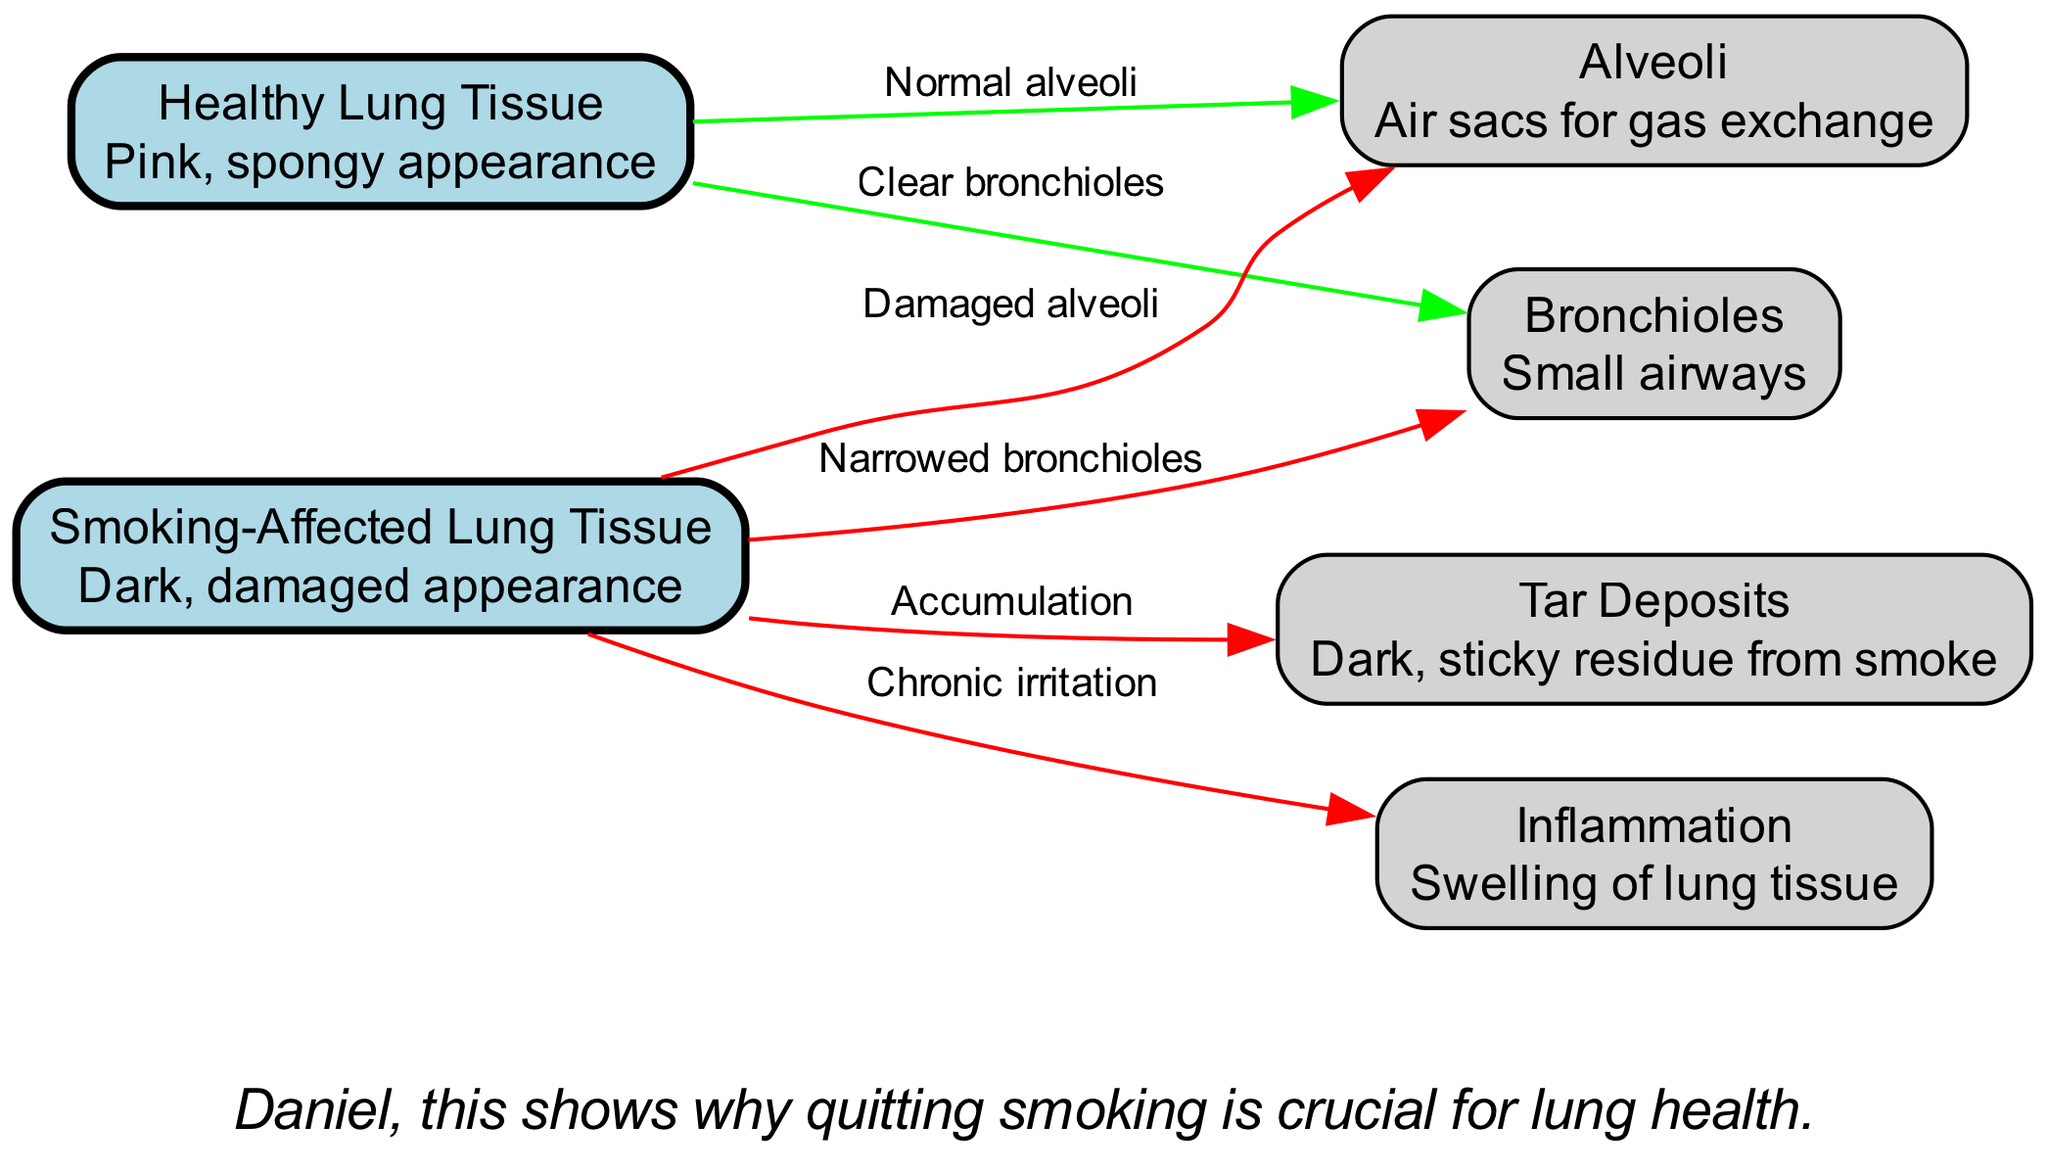What is the color of healthy lung tissue? The diagram indicates that healthy lung tissue is represented with a "Pink, spongy appearance" description.
Answer: Pink, spongy How many types of lung tissue are compared in the diagram? The diagram shows two distinct types of lung tissues for comparison: healthy lung tissue and smoking-affected lung tissue.
Answer: Two What is the label for the relationship between healthy lung tissue and alveoli? The edge connecting healthy lung tissue to alveoli is labeled "Normal alveoli," indicating a healthy interaction.
Answer: Normal alveoli What is the consequence of smoking on bronchioles as depicted? The diagram illustrates that smoking-affected lung tissue causes "Narrowed bronchioles," indicating a detrimental effect on airways.
Answer: Narrowed bronchioles What is found on smoking-affected lung tissue that is not present on healthy lung tissue? The diagram reveals that smoking-affected lung tissue has "Tar Deposits," which are not present on healthy lung tissue, illustrating the accumulation of harmful residues from smoking.
Answer: Tar Deposits What does inflammation signify in the context of smoking-affected lung tissue? According to the diagram, "Inflammation" represents "Swelling of lung tissue," indicating a response to chronic irritation caused by smoking.
Answer: Swelling What are the visual differences between healthy and smoking-affected lung tissue? The diagram shows that healthy lung tissue has a "Pink, spongy appearance," while smoking-affected lung tissue has a "Dark, damaged appearance," highlighting the physical impact of smoking.
Answer: Pink, spongy and dark, damaged Which aspect of lung health emphasizes the importance of quitting smoking? The note at the bottom of the diagram emphasizes that the comparison illustrates "why quitting smoking is crucial for lung health," highlighting the overall message and conclusion derived from the visual information.
Answer: Crucial for lung health 